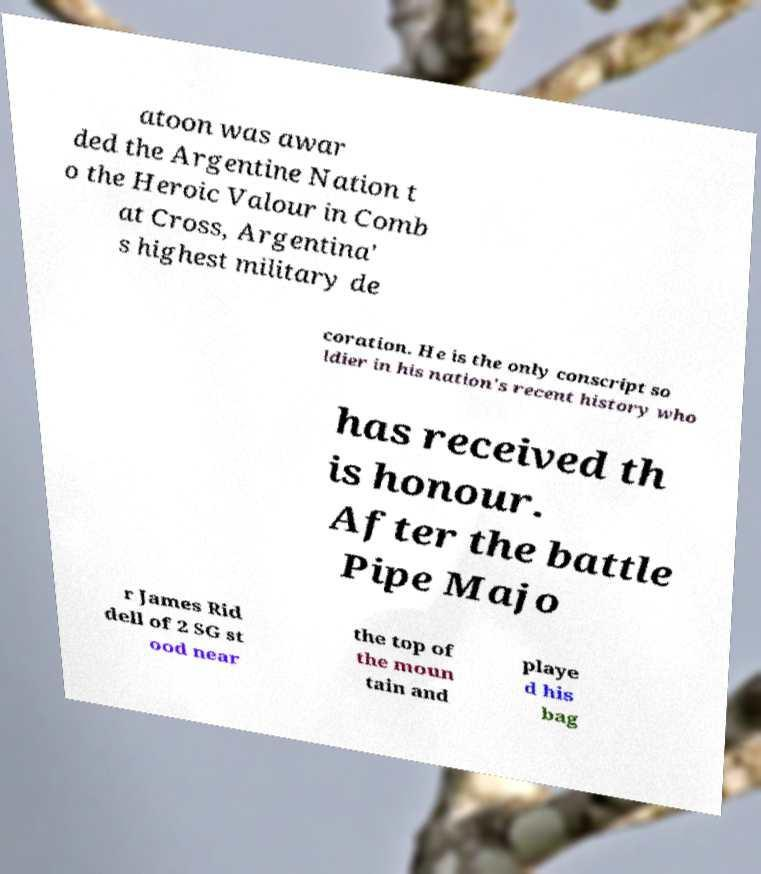Can you accurately transcribe the text from the provided image for me? atoon was awar ded the Argentine Nation t o the Heroic Valour in Comb at Cross, Argentina' s highest military de coration. He is the only conscript so ldier in his nation's recent history who has received th is honour. After the battle Pipe Majo r James Rid dell of 2 SG st ood near the top of the moun tain and playe d his bag 